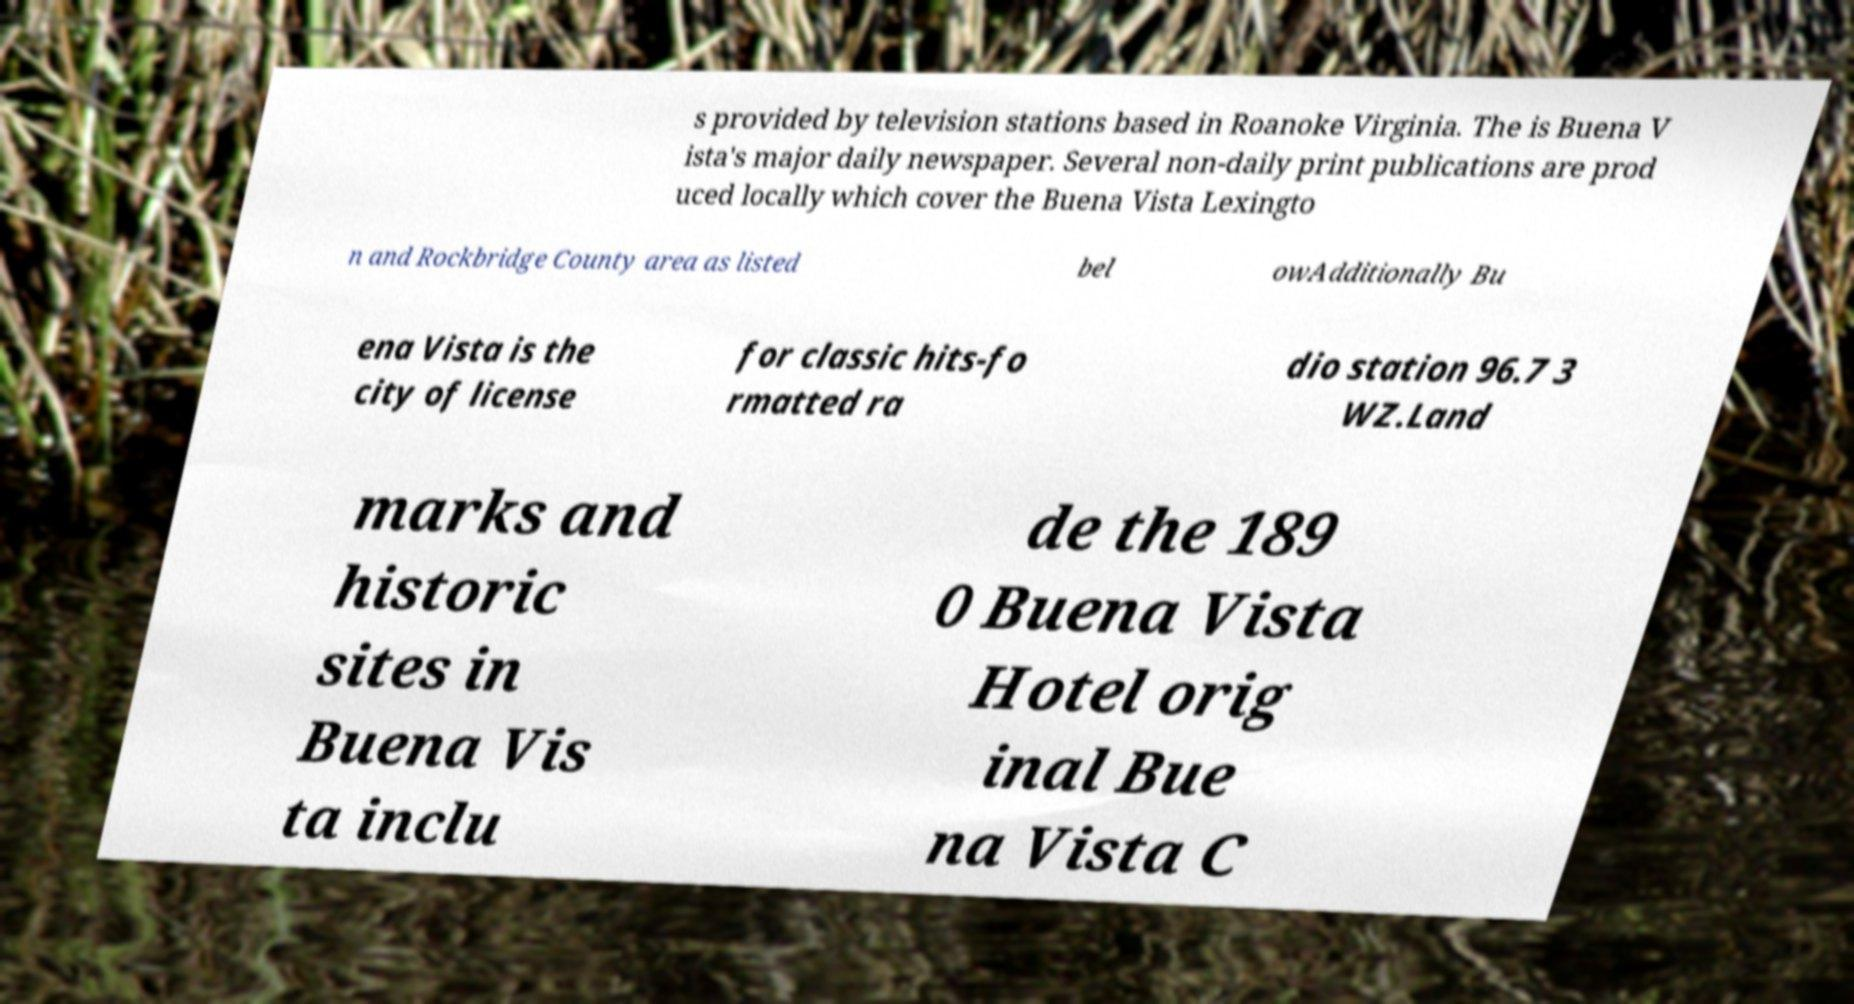I need the written content from this picture converted into text. Can you do that? s provided by television stations based in Roanoke Virginia. The is Buena V ista's major daily newspaper. Several non-daily print publications are prod uced locally which cover the Buena Vista Lexingto n and Rockbridge County area as listed bel owAdditionally Bu ena Vista is the city of license for classic hits-fo rmatted ra dio station 96.7 3 WZ.Land marks and historic sites in Buena Vis ta inclu de the 189 0 Buena Vista Hotel orig inal Bue na Vista C 